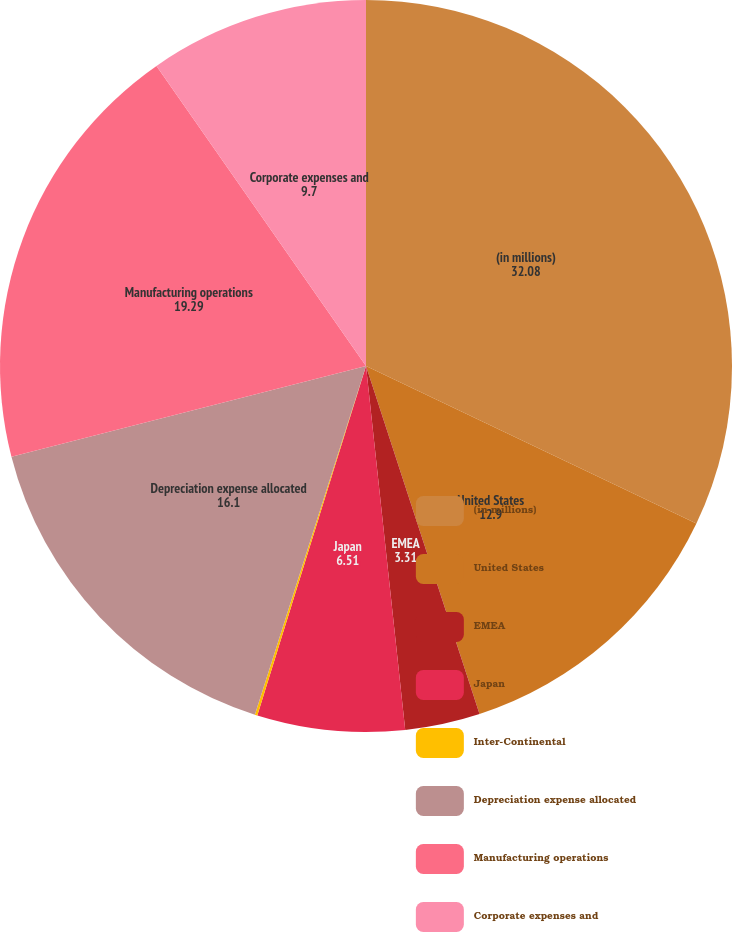<chart> <loc_0><loc_0><loc_500><loc_500><pie_chart><fcel>(in millions)<fcel>United States<fcel>EMEA<fcel>Japan<fcel>Inter-Continental<fcel>Depreciation expense allocated<fcel>Manufacturing operations<fcel>Corporate expenses and<nl><fcel>32.08%<fcel>12.9%<fcel>3.31%<fcel>6.51%<fcel>0.11%<fcel>16.1%<fcel>19.29%<fcel>9.7%<nl></chart> 